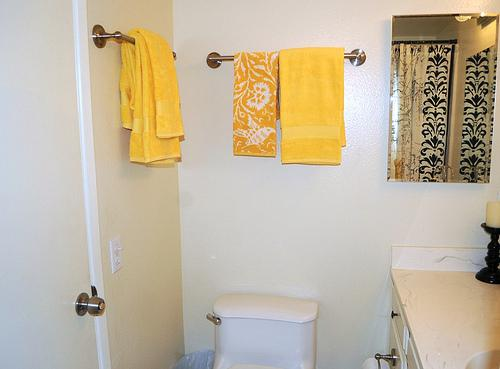Question: how many toilets are in the photo?
Choices:
A. Two.
B. Three.
C. Five.
D. One.
Answer with the letter. Answer: D Question: what color toilet in pictured?
Choices:
A. Bisque.
B. White.
C. Cream.
D. Gold.
Answer with the letter. Answer: B Question: where was this photo taken?
Choices:
A. A bedroom.
B. A bathroom.
C. A kitchen.
D. A sports arena.
Answer with the letter. Answer: B Question: what color towels are hanging?
Choices:
A. White.
B. Yellow.
C. Blue.
D. Black.
Answer with the letter. Answer: B Question: what color handle does the door to the bathroom have?
Choices:
A. Nickel.
B. Gold.
C. Silver.
D. Brass.
Answer with the letter. Answer: C Question: how many doors are in the bathroom?
Choices:
A. One.
B. Two.
C. Five.
D. Four.
Answer with the letter. Answer: A 